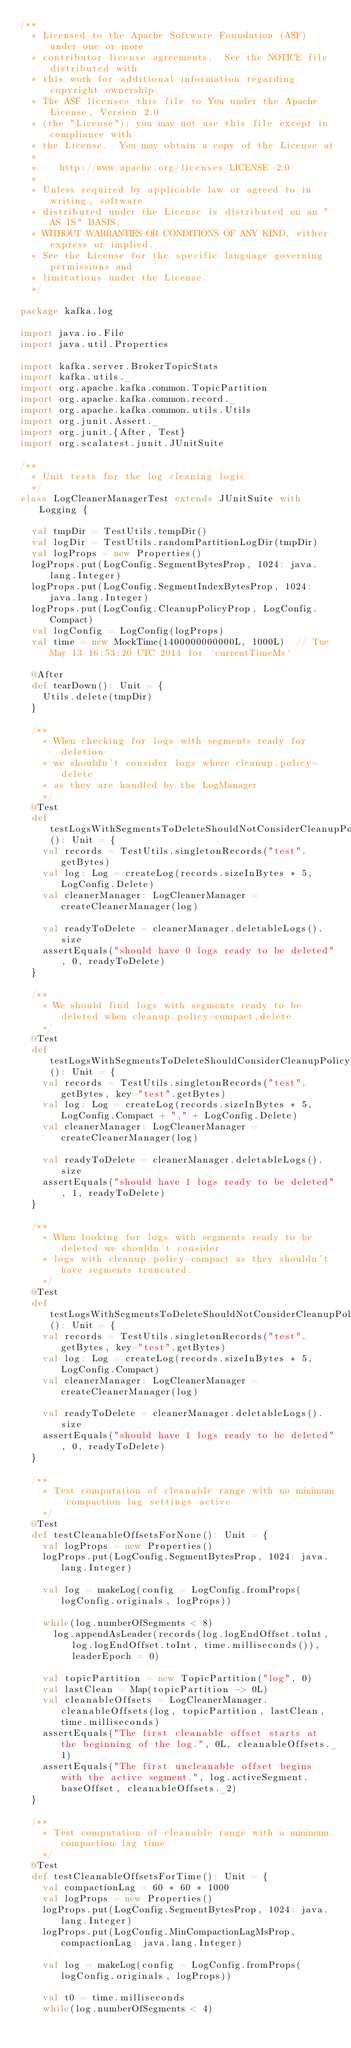<code> <loc_0><loc_0><loc_500><loc_500><_Scala_>/**
  * Licensed to the Apache Software Foundation (ASF) under one or more
  * contributor license agreements.  See the NOTICE file distributed with
  * this work for additional information regarding copyright ownership.
  * The ASF licenses this file to You under the Apache License, Version 2.0
  * (the "License"); you may not use this file except in compliance with
  * the License.  You may obtain a copy of the License at
  *
  *    http://www.apache.org/licenses/LICENSE-2.0
  *
  * Unless required by applicable law or agreed to in writing, software
  * distributed under the License is distributed on an "AS IS" BASIS,
  * WITHOUT WARRANTIES OR CONDITIONS OF ANY KIND, either express or implied.
  * See the License for the specific language governing permissions and
  * limitations under the License.
  */

package kafka.log

import java.io.File
import java.util.Properties

import kafka.server.BrokerTopicStats
import kafka.utils._
import org.apache.kafka.common.TopicPartition
import org.apache.kafka.common.record._
import org.apache.kafka.common.utils.Utils
import org.junit.Assert._
import org.junit.{After, Test}
import org.scalatest.junit.JUnitSuite

/**
  * Unit tests for the log cleaning logic
  */
class LogCleanerManagerTest extends JUnitSuite with Logging {

  val tmpDir = TestUtils.tempDir()
  val logDir = TestUtils.randomPartitionLogDir(tmpDir)
  val logProps = new Properties()
  logProps.put(LogConfig.SegmentBytesProp, 1024: java.lang.Integer)
  logProps.put(LogConfig.SegmentIndexBytesProp, 1024: java.lang.Integer)
  logProps.put(LogConfig.CleanupPolicyProp, LogConfig.Compact)
  val logConfig = LogConfig(logProps)
  val time = new MockTime(1400000000000L, 1000L)  // Tue May 13 16:53:20 UTC 2014 for `currentTimeMs`

  @After
  def tearDown(): Unit = {
    Utils.delete(tmpDir)
  }

  /**
    * When checking for logs with segments ready for deletion
    * we shouldn't consider logs where cleanup.policy=delete
    * as they are handled by the LogManager
    */
  @Test
  def testLogsWithSegmentsToDeleteShouldNotConsiderCleanupPolicyDeleteLogs(): Unit = {
    val records = TestUtils.singletonRecords("test".getBytes)
    val log: Log = createLog(records.sizeInBytes * 5, LogConfig.Delete)
    val cleanerManager: LogCleanerManager = createCleanerManager(log)

    val readyToDelete = cleanerManager.deletableLogs().size
    assertEquals("should have 0 logs ready to be deleted", 0, readyToDelete)
  }

  /**
    * We should find logs with segments ready to be deleted when cleanup.policy=compact,delete
    */
  @Test
  def testLogsWithSegmentsToDeleteShouldConsiderCleanupPolicyCompactDeleteLogs(): Unit = {
    val records = TestUtils.singletonRecords("test".getBytes, key="test".getBytes)
    val log: Log = createLog(records.sizeInBytes * 5, LogConfig.Compact + "," + LogConfig.Delete)
    val cleanerManager: LogCleanerManager = createCleanerManager(log)

    val readyToDelete = cleanerManager.deletableLogs().size
    assertEquals("should have 1 logs ready to be deleted", 1, readyToDelete)
  }

  /**
    * When looking for logs with segments ready to be deleted we shouldn't consider
    * logs with cleanup.policy=compact as they shouldn't have segments truncated.
    */
  @Test
  def testLogsWithSegmentsToDeleteShouldNotConsiderCleanupPolicyCompactLogs(): Unit = {
    val records = TestUtils.singletonRecords("test".getBytes, key="test".getBytes)
    val log: Log = createLog(records.sizeInBytes * 5, LogConfig.Compact)
    val cleanerManager: LogCleanerManager = createCleanerManager(log)

    val readyToDelete = cleanerManager.deletableLogs().size
    assertEquals("should have 1 logs ready to be deleted", 0, readyToDelete)
  }

  /**
    * Test computation of cleanable range with no minimum compaction lag settings active
    */
  @Test
  def testCleanableOffsetsForNone(): Unit = {
    val logProps = new Properties()
    logProps.put(LogConfig.SegmentBytesProp, 1024: java.lang.Integer)

    val log = makeLog(config = LogConfig.fromProps(logConfig.originals, logProps))

    while(log.numberOfSegments < 8)
      log.appendAsLeader(records(log.logEndOffset.toInt, log.logEndOffset.toInt, time.milliseconds()), leaderEpoch = 0)

    val topicPartition = new TopicPartition("log", 0)
    val lastClean = Map(topicPartition -> 0L)
    val cleanableOffsets = LogCleanerManager.cleanableOffsets(log, topicPartition, lastClean, time.milliseconds)
    assertEquals("The first cleanable offset starts at the beginning of the log.", 0L, cleanableOffsets._1)
    assertEquals("The first uncleanable offset begins with the active segment.", log.activeSegment.baseOffset, cleanableOffsets._2)
  }

  /**
    * Test computation of cleanable range with a minimum compaction lag time
    */
  @Test
  def testCleanableOffsetsForTime(): Unit = {
    val compactionLag = 60 * 60 * 1000
    val logProps = new Properties()
    logProps.put(LogConfig.SegmentBytesProp, 1024: java.lang.Integer)
    logProps.put(LogConfig.MinCompactionLagMsProp, compactionLag: java.lang.Integer)

    val log = makeLog(config = LogConfig.fromProps(logConfig.originals, logProps))

    val t0 = time.milliseconds
    while(log.numberOfSegments < 4)</code> 